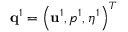Convert formula to latex. <formula><loc_0><loc_0><loc_500><loc_500>{ q } ^ { 1 } = \left ( { u } ^ { 1 } , p ^ { 1 } , \eta ^ { 1 } \right ) ^ { T }</formula> 